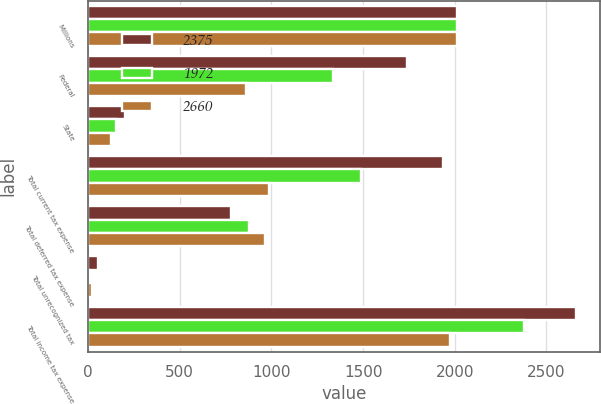<chart> <loc_0><loc_0><loc_500><loc_500><stacked_bar_chart><ecel><fcel>Millions<fcel>Federal<fcel>State<fcel>Total current tax expense<fcel>Total deferred tax expense<fcel>Total unrecognized tax<fcel>Total income tax expense<nl><fcel>2375<fcel>2013<fcel>1738<fcel>199<fcel>1937<fcel>778<fcel>55<fcel>2660<nl><fcel>1972<fcel>2012<fcel>1335<fcel>153<fcel>1488<fcel>880<fcel>7<fcel>2375<nl><fcel>2660<fcel>2011<fcel>862<fcel>124<fcel>986<fcel>964<fcel>22<fcel>1972<nl></chart> 